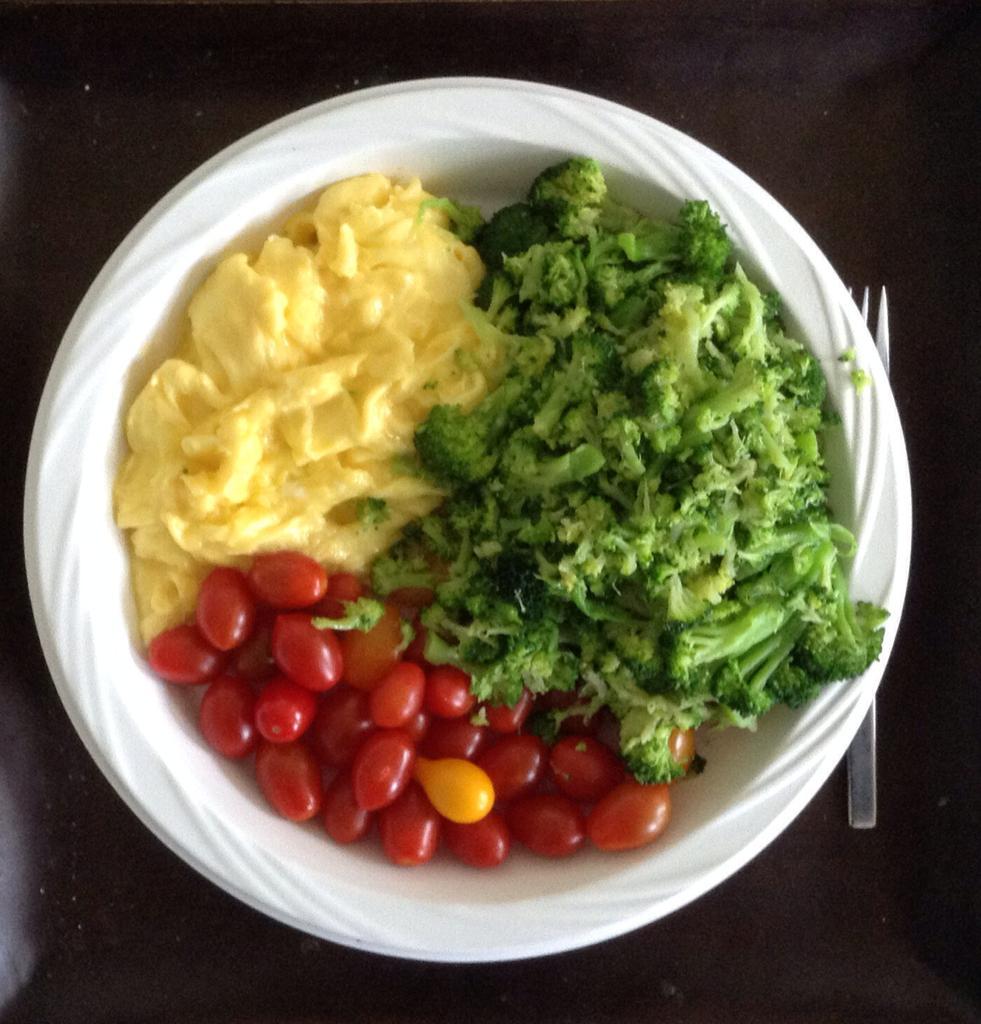Please provide a concise description of this image. In this image there are food items in a paper bowl and a fork on the table. 